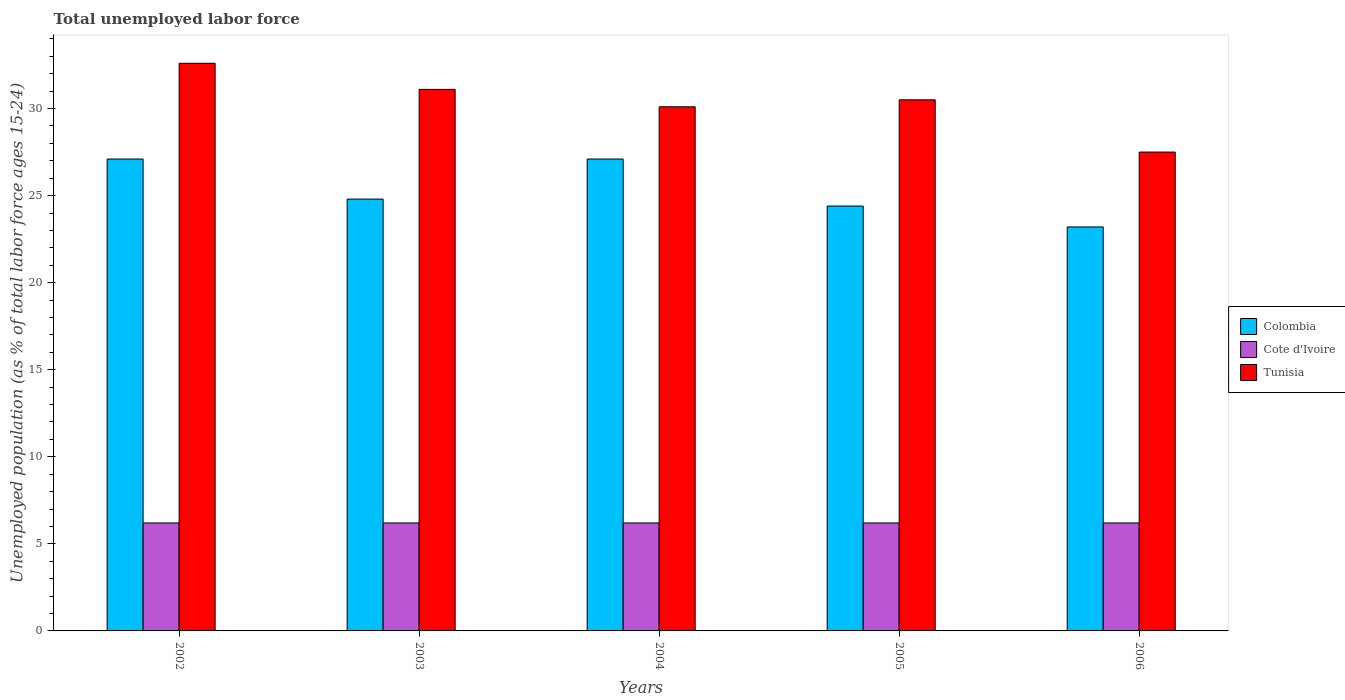Are the number of bars on each tick of the X-axis equal?
Provide a succinct answer. Yes. How many bars are there on the 4th tick from the left?
Offer a very short reply. 3. How many bars are there on the 2nd tick from the right?
Provide a succinct answer. 3. What is the label of the 3rd group of bars from the left?
Make the answer very short. 2004. In how many cases, is the number of bars for a given year not equal to the number of legend labels?
Keep it short and to the point. 0. What is the percentage of unemployed population in in Cote d'Ivoire in 2005?
Your response must be concise. 6.2. Across all years, what is the maximum percentage of unemployed population in in Tunisia?
Give a very brief answer. 32.6. Across all years, what is the minimum percentage of unemployed population in in Cote d'Ivoire?
Offer a terse response. 6.2. In which year was the percentage of unemployed population in in Cote d'Ivoire minimum?
Ensure brevity in your answer.  2002. What is the total percentage of unemployed population in in Cote d'Ivoire in the graph?
Provide a succinct answer. 31. What is the difference between the percentage of unemployed population in in Cote d'Ivoire in 2002 and that in 2004?
Your answer should be compact. 0. What is the difference between the percentage of unemployed population in in Tunisia in 2005 and the percentage of unemployed population in in Cote d'Ivoire in 2004?
Offer a terse response. 24.3. What is the average percentage of unemployed population in in Cote d'Ivoire per year?
Provide a short and direct response. 6.2. In the year 2002, what is the difference between the percentage of unemployed population in in Colombia and percentage of unemployed population in in Tunisia?
Keep it short and to the point. -5.5. In how many years, is the percentage of unemployed population in in Colombia greater than 33 %?
Your response must be concise. 0. What is the ratio of the percentage of unemployed population in in Tunisia in 2004 to that in 2005?
Provide a succinct answer. 0.99. Is the percentage of unemployed population in in Tunisia in 2002 less than that in 2003?
Keep it short and to the point. No. What is the difference between the highest and the second highest percentage of unemployed population in in Tunisia?
Ensure brevity in your answer.  1.5. What is the difference between the highest and the lowest percentage of unemployed population in in Tunisia?
Provide a succinct answer. 5.1. What does the 1st bar from the left in 2004 represents?
Your answer should be compact. Colombia. What does the 2nd bar from the right in 2006 represents?
Give a very brief answer. Cote d'Ivoire. Is it the case that in every year, the sum of the percentage of unemployed population in in Colombia and percentage of unemployed population in in Cote d'Ivoire is greater than the percentage of unemployed population in in Tunisia?
Provide a short and direct response. No. Are all the bars in the graph horizontal?
Provide a short and direct response. No. How many years are there in the graph?
Ensure brevity in your answer.  5. Are the values on the major ticks of Y-axis written in scientific E-notation?
Ensure brevity in your answer.  No. Does the graph contain any zero values?
Give a very brief answer. No. How are the legend labels stacked?
Give a very brief answer. Vertical. What is the title of the graph?
Your answer should be very brief. Total unemployed labor force. What is the label or title of the X-axis?
Ensure brevity in your answer.  Years. What is the label or title of the Y-axis?
Provide a short and direct response. Unemployed population (as % of total labor force ages 15-24). What is the Unemployed population (as % of total labor force ages 15-24) of Colombia in 2002?
Your answer should be very brief. 27.1. What is the Unemployed population (as % of total labor force ages 15-24) of Cote d'Ivoire in 2002?
Offer a very short reply. 6.2. What is the Unemployed population (as % of total labor force ages 15-24) in Tunisia in 2002?
Provide a short and direct response. 32.6. What is the Unemployed population (as % of total labor force ages 15-24) of Colombia in 2003?
Your response must be concise. 24.8. What is the Unemployed population (as % of total labor force ages 15-24) of Cote d'Ivoire in 2003?
Keep it short and to the point. 6.2. What is the Unemployed population (as % of total labor force ages 15-24) of Tunisia in 2003?
Your answer should be compact. 31.1. What is the Unemployed population (as % of total labor force ages 15-24) in Colombia in 2004?
Give a very brief answer. 27.1. What is the Unemployed population (as % of total labor force ages 15-24) in Cote d'Ivoire in 2004?
Offer a terse response. 6.2. What is the Unemployed population (as % of total labor force ages 15-24) in Tunisia in 2004?
Ensure brevity in your answer.  30.1. What is the Unemployed population (as % of total labor force ages 15-24) of Colombia in 2005?
Provide a short and direct response. 24.4. What is the Unemployed population (as % of total labor force ages 15-24) in Cote d'Ivoire in 2005?
Keep it short and to the point. 6.2. What is the Unemployed population (as % of total labor force ages 15-24) of Tunisia in 2005?
Your response must be concise. 30.5. What is the Unemployed population (as % of total labor force ages 15-24) of Colombia in 2006?
Give a very brief answer. 23.2. What is the Unemployed population (as % of total labor force ages 15-24) in Cote d'Ivoire in 2006?
Your answer should be compact. 6.2. What is the Unemployed population (as % of total labor force ages 15-24) in Tunisia in 2006?
Give a very brief answer. 27.5. Across all years, what is the maximum Unemployed population (as % of total labor force ages 15-24) of Colombia?
Keep it short and to the point. 27.1. Across all years, what is the maximum Unemployed population (as % of total labor force ages 15-24) in Cote d'Ivoire?
Offer a very short reply. 6.2. Across all years, what is the maximum Unemployed population (as % of total labor force ages 15-24) of Tunisia?
Provide a short and direct response. 32.6. Across all years, what is the minimum Unemployed population (as % of total labor force ages 15-24) of Colombia?
Make the answer very short. 23.2. Across all years, what is the minimum Unemployed population (as % of total labor force ages 15-24) of Cote d'Ivoire?
Your answer should be very brief. 6.2. What is the total Unemployed population (as % of total labor force ages 15-24) in Colombia in the graph?
Provide a succinct answer. 126.6. What is the total Unemployed population (as % of total labor force ages 15-24) in Cote d'Ivoire in the graph?
Provide a succinct answer. 31. What is the total Unemployed population (as % of total labor force ages 15-24) of Tunisia in the graph?
Offer a terse response. 151.8. What is the difference between the Unemployed population (as % of total labor force ages 15-24) of Tunisia in 2002 and that in 2003?
Your answer should be compact. 1.5. What is the difference between the Unemployed population (as % of total labor force ages 15-24) of Colombia in 2002 and that in 2004?
Your answer should be compact. 0. What is the difference between the Unemployed population (as % of total labor force ages 15-24) in Tunisia in 2002 and that in 2004?
Your answer should be compact. 2.5. What is the difference between the Unemployed population (as % of total labor force ages 15-24) in Colombia in 2002 and that in 2005?
Your answer should be very brief. 2.7. What is the difference between the Unemployed population (as % of total labor force ages 15-24) in Colombia in 2002 and that in 2006?
Your answer should be compact. 3.9. What is the difference between the Unemployed population (as % of total labor force ages 15-24) of Colombia in 2003 and that in 2004?
Your answer should be very brief. -2.3. What is the difference between the Unemployed population (as % of total labor force ages 15-24) in Cote d'Ivoire in 2003 and that in 2004?
Ensure brevity in your answer.  0. What is the difference between the Unemployed population (as % of total labor force ages 15-24) in Tunisia in 2003 and that in 2004?
Your answer should be very brief. 1. What is the difference between the Unemployed population (as % of total labor force ages 15-24) in Cote d'Ivoire in 2003 and that in 2005?
Ensure brevity in your answer.  0. What is the difference between the Unemployed population (as % of total labor force ages 15-24) of Tunisia in 2003 and that in 2005?
Your response must be concise. 0.6. What is the difference between the Unemployed population (as % of total labor force ages 15-24) in Colombia in 2003 and that in 2006?
Provide a succinct answer. 1.6. What is the difference between the Unemployed population (as % of total labor force ages 15-24) in Tunisia in 2004 and that in 2005?
Your answer should be very brief. -0.4. What is the difference between the Unemployed population (as % of total labor force ages 15-24) of Cote d'Ivoire in 2004 and that in 2006?
Ensure brevity in your answer.  0. What is the difference between the Unemployed population (as % of total labor force ages 15-24) in Tunisia in 2004 and that in 2006?
Keep it short and to the point. 2.6. What is the difference between the Unemployed population (as % of total labor force ages 15-24) of Tunisia in 2005 and that in 2006?
Give a very brief answer. 3. What is the difference between the Unemployed population (as % of total labor force ages 15-24) of Colombia in 2002 and the Unemployed population (as % of total labor force ages 15-24) of Cote d'Ivoire in 2003?
Your answer should be very brief. 20.9. What is the difference between the Unemployed population (as % of total labor force ages 15-24) of Colombia in 2002 and the Unemployed population (as % of total labor force ages 15-24) of Tunisia in 2003?
Provide a short and direct response. -4. What is the difference between the Unemployed population (as % of total labor force ages 15-24) of Cote d'Ivoire in 2002 and the Unemployed population (as % of total labor force ages 15-24) of Tunisia in 2003?
Provide a short and direct response. -24.9. What is the difference between the Unemployed population (as % of total labor force ages 15-24) in Colombia in 2002 and the Unemployed population (as % of total labor force ages 15-24) in Cote d'Ivoire in 2004?
Ensure brevity in your answer.  20.9. What is the difference between the Unemployed population (as % of total labor force ages 15-24) of Cote d'Ivoire in 2002 and the Unemployed population (as % of total labor force ages 15-24) of Tunisia in 2004?
Provide a succinct answer. -23.9. What is the difference between the Unemployed population (as % of total labor force ages 15-24) of Colombia in 2002 and the Unemployed population (as % of total labor force ages 15-24) of Cote d'Ivoire in 2005?
Give a very brief answer. 20.9. What is the difference between the Unemployed population (as % of total labor force ages 15-24) of Cote d'Ivoire in 2002 and the Unemployed population (as % of total labor force ages 15-24) of Tunisia in 2005?
Offer a very short reply. -24.3. What is the difference between the Unemployed population (as % of total labor force ages 15-24) in Colombia in 2002 and the Unemployed population (as % of total labor force ages 15-24) in Cote d'Ivoire in 2006?
Offer a terse response. 20.9. What is the difference between the Unemployed population (as % of total labor force ages 15-24) of Cote d'Ivoire in 2002 and the Unemployed population (as % of total labor force ages 15-24) of Tunisia in 2006?
Make the answer very short. -21.3. What is the difference between the Unemployed population (as % of total labor force ages 15-24) in Colombia in 2003 and the Unemployed population (as % of total labor force ages 15-24) in Tunisia in 2004?
Make the answer very short. -5.3. What is the difference between the Unemployed population (as % of total labor force ages 15-24) of Cote d'Ivoire in 2003 and the Unemployed population (as % of total labor force ages 15-24) of Tunisia in 2004?
Keep it short and to the point. -23.9. What is the difference between the Unemployed population (as % of total labor force ages 15-24) in Colombia in 2003 and the Unemployed population (as % of total labor force ages 15-24) in Cote d'Ivoire in 2005?
Your response must be concise. 18.6. What is the difference between the Unemployed population (as % of total labor force ages 15-24) in Colombia in 2003 and the Unemployed population (as % of total labor force ages 15-24) in Tunisia in 2005?
Offer a very short reply. -5.7. What is the difference between the Unemployed population (as % of total labor force ages 15-24) in Cote d'Ivoire in 2003 and the Unemployed population (as % of total labor force ages 15-24) in Tunisia in 2005?
Give a very brief answer. -24.3. What is the difference between the Unemployed population (as % of total labor force ages 15-24) in Colombia in 2003 and the Unemployed population (as % of total labor force ages 15-24) in Cote d'Ivoire in 2006?
Make the answer very short. 18.6. What is the difference between the Unemployed population (as % of total labor force ages 15-24) of Colombia in 2003 and the Unemployed population (as % of total labor force ages 15-24) of Tunisia in 2006?
Your response must be concise. -2.7. What is the difference between the Unemployed population (as % of total labor force ages 15-24) of Cote d'Ivoire in 2003 and the Unemployed population (as % of total labor force ages 15-24) of Tunisia in 2006?
Ensure brevity in your answer.  -21.3. What is the difference between the Unemployed population (as % of total labor force ages 15-24) of Colombia in 2004 and the Unemployed population (as % of total labor force ages 15-24) of Cote d'Ivoire in 2005?
Provide a succinct answer. 20.9. What is the difference between the Unemployed population (as % of total labor force ages 15-24) in Colombia in 2004 and the Unemployed population (as % of total labor force ages 15-24) in Tunisia in 2005?
Your answer should be very brief. -3.4. What is the difference between the Unemployed population (as % of total labor force ages 15-24) of Cote d'Ivoire in 2004 and the Unemployed population (as % of total labor force ages 15-24) of Tunisia in 2005?
Your response must be concise. -24.3. What is the difference between the Unemployed population (as % of total labor force ages 15-24) in Colombia in 2004 and the Unemployed population (as % of total labor force ages 15-24) in Cote d'Ivoire in 2006?
Keep it short and to the point. 20.9. What is the difference between the Unemployed population (as % of total labor force ages 15-24) in Cote d'Ivoire in 2004 and the Unemployed population (as % of total labor force ages 15-24) in Tunisia in 2006?
Provide a short and direct response. -21.3. What is the difference between the Unemployed population (as % of total labor force ages 15-24) in Cote d'Ivoire in 2005 and the Unemployed population (as % of total labor force ages 15-24) in Tunisia in 2006?
Provide a succinct answer. -21.3. What is the average Unemployed population (as % of total labor force ages 15-24) of Colombia per year?
Your answer should be very brief. 25.32. What is the average Unemployed population (as % of total labor force ages 15-24) in Cote d'Ivoire per year?
Your answer should be very brief. 6.2. What is the average Unemployed population (as % of total labor force ages 15-24) in Tunisia per year?
Offer a very short reply. 30.36. In the year 2002, what is the difference between the Unemployed population (as % of total labor force ages 15-24) in Colombia and Unemployed population (as % of total labor force ages 15-24) in Cote d'Ivoire?
Provide a short and direct response. 20.9. In the year 2002, what is the difference between the Unemployed population (as % of total labor force ages 15-24) of Colombia and Unemployed population (as % of total labor force ages 15-24) of Tunisia?
Your answer should be compact. -5.5. In the year 2002, what is the difference between the Unemployed population (as % of total labor force ages 15-24) in Cote d'Ivoire and Unemployed population (as % of total labor force ages 15-24) in Tunisia?
Offer a very short reply. -26.4. In the year 2003, what is the difference between the Unemployed population (as % of total labor force ages 15-24) in Colombia and Unemployed population (as % of total labor force ages 15-24) in Tunisia?
Give a very brief answer. -6.3. In the year 2003, what is the difference between the Unemployed population (as % of total labor force ages 15-24) of Cote d'Ivoire and Unemployed population (as % of total labor force ages 15-24) of Tunisia?
Keep it short and to the point. -24.9. In the year 2004, what is the difference between the Unemployed population (as % of total labor force ages 15-24) of Colombia and Unemployed population (as % of total labor force ages 15-24) of Cote d'Ivoire?
Your response must be concise. 20.9. In the year 2004, what is the difference between the Unemployed population (as % of total labor force ages 15-24) of Colombia and Unemployed population (as % of total labor force ages 15-24) of Tunisia?
Make the answer very short. -3. In the year 2004, what is the difference between the Unemployed population (as % of total labor force ages 15-24) of Cote d'Ivoire and Unemployed population (as % of total labor force ages 15-24) of Tunisia?
Your answer should be very brief. -23.9. In the year 2005, what is the difference between the Unemployed population (as % of total labor force ages 15-24) in Colombia and Unemployed population (as % of total labor force ages 15-24) in Tunisia?
Provide a succinct answer. -6.1. In the year 2005, what is the difference between the Unemployed population (as % of total labor force ages 15-24) of Cote d'Ivoire and Unemployed population (as % of total labor force ages 15-24) of Tunisia?
Ensure brevity in your answer.  -24.3. In the year 2006, what is the difference between the Unemployed population (as % of total labor force ages 15-24) in Colombia and Unemployed population (as % of total labor force ages 15-24) in Cote d'Ivoire?
Provide a short and direct response. 17. In the year 2006, what is the difference between the Unemployed population (as % of total labor force ages 15-24) in Colombia and Unemployed population (as % of total labor force ages 15-24) in Tunisia?
Your response must be concise. -4.3. In the year 2006, what is the difference between the Unemployed population (as % of total labor force ages 15-24) in Cote d'Ivoire and Unemployed population (as % of total labor force ages 15-24) in Tunisia?
Provide a short and direct response. -21.3. What is the ratio of the Unemployed population (as % of total labor force ages 15-24) in Colombia in 2002 to that in 2003?
Provide a succinct answer. 1.09. What is the ratio of the Unemployed population (as % of total labor force ages 15-24) of Tunisia in 2002 to that in 2003?
Your response must be concise. 1.05. What is the ratio of the Unemployed population (as % of total labor force ages 15-24) of Tunisia in 2002 to that in 2004?
Offer a very short reply. 1.08. What is the ratio of the Unemployed population (as % of total labor force ages 15-24) of Colombia in 2002 to that in 2005?
Provide a short and direct response. 1.11. What is the ratio of the Unemployed population (as % of total labor force ages 15-24) in Cote d'Ivoire in 2002 to that in 2005?
Provide a succinct answer. 1. What is the ratio of the Unemployed population (as % of total labor force ages 15-24) of Tunisia in 2002 to that in 2005?
Offer a terse response. 1.07. What is the ratio of the Unemployed population (as % of total labor force ages 15-24) of Colombia in 2002 to that in 2006?
Provide a succinct answer. 1.17. What is the ratio of the Unemployed population (as % of total labor force ages 15-24) in Tunisia in 2002 to that in 2006?
Your response must be concise. 1.19. What is the ratio of the Unemployed population (as % of total labor force ages 15-24) in Colombia in 2003 to that in 2004?
Your answer should be compact. 0.92. What is the ratio of the Unemployed population (as % of total labor force ages 15-24) of Tunisia in 2003 to that in 2004?
Your answer should be very brief. 1.03. What is the ratio of the Unemployed population (as % of total labor force ages 15-24) of Colombia in 2003 to that in 2005?
Ensure brevity in your answer.  1.02. What is the ratio of the Unemployed population (as % of total labor force ages 15-24) in Cote d'Ivoire in 2003 to that in 2005?
Ensure brevity in your answer.  1. What is the ratio of the Unemployed population (as % of total labor force ages 15-24) of Tunisia in 2003 to that in 2005?
Give a very brief answer. 1.02. What is the ratio of the Unemployed population (as % of total labor force ages 15-24) in Colombia in 2003 to that in 2006?
Give a very brief answer. 1.07. What is the ratio of the Unemployed population (as % of total labor force ages 15-24) of Cote d'Ivoire in 2003 to that in 2006?
Give a very brief answer. 1. What is the ratio of the Unemployed population (as % of total labor force ages 15-24) in Tunisia in 2003 to that in 2006?
Provide a succinct answer. 1.13. What is the ratio of the Unemployed population (as % of total labor force ages 15-24) of Colombia in 2004 to that in 2005?
Your answer should be very brief. 1.11. What is the ratio of the Unemployed population (as % of total labor force ages 15-24) of Cote d'Ivoire in 2004 to that in 2005?
Your answer should be compact. 1. What is the ratio of the Unemployed population (as % of total labor force ages 15-24) in Tunisia in 2004 to that in 2005?
Provide a succinct answer. 0.99. What is the ratio of the Unemployed population (as % of total labor force ages 15-24) in Colombia in 2004 to that in 2006?
Provide a succinct answer. 1.17. What is the ratio of the Unemployed population (as % of total labor force ages 15-24) in Cote d'Ivoire in 2004 to that in 2006?
Ensure brevity in your answer.  1. What is the ratio of the Unemployed population (as % of total labor force ages 15-24) in Tunisia in 2004 to that in 2006?
Offer a very short reply. 1.09. What is the ratio of the Unemployed population (as % of total labor force ages 15-24) of Colombia in 2005 to that in 2006?
Provide a succinct answer. 1.05. What is the ratio of the Unemployed population (as % of total labor force ages 15-24) in Cote d'Ivoire in 2005 to that in 2006?
Offer a very short reply. 1. What is the ratio of the Unemployed population (as % of total labor force ages 15-24) in Tunisia in 2005 to that in 2006?
Provide a short and direct response. 1.11. What is the difference between the highest and the second highest Unemployed population (as % of total labor force ages 15-24) of Tunisia?
Ensure brevity in your answer.  1.5. What is the difference between the highest and the lowest Unemployed population (as % of total labor force ages 15-24) in Colombia?
Ensure brevity in your answer.  3.9. What is the difference between the highest and the lowest Unemployed population (as % of total labor force ages 15-24) in Cote d'Ivoire?
Your answer should be very brief. 0. 